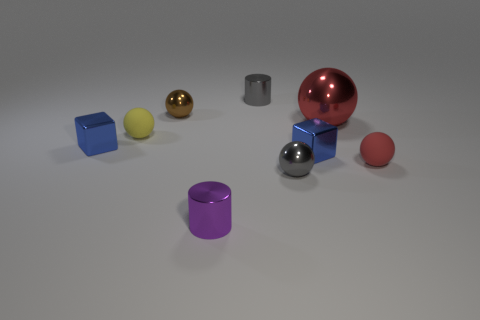Subtract all tiny brown balls. How many balls are left? 4 Subtract all purple blocks. How many red spheres are left? 2 Add 1 small yellow matte balls. How many objects exist? 10 Subtract all brown spheres. How many spheres are left? 4 Subtract 1 spheres. How many spheres are left? 4 Subtract all spheres. How many objects are left? 4 Subtract all gray spheres. Subtract all blue cylinders. How many spheres are left? 4 Subtract all big red metal balls. Subtract all tiny gray metal balls. How many objects are left? 7 Add 6 tiny purple metal cylinders. How many tiny purple metal cylinders are left? 7 Add 1 red metallic cylinders. How many red metallic cylinders exist? 1 